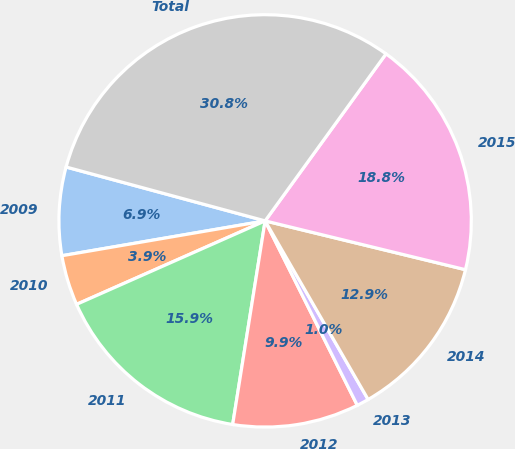Convert chart to OTSL. <chart><loc_0><loc_0><loc_500><loc_500><pie_chart><fcel>2009<fcel>2010<fcel>2011<fcel>2012<fcel>2013<fcel>2014<fcel>2015<fcel>Total<nl><fcel>6.91%<fcel>3.93%<fcel>15.85%<fcel>9.89%<fcel>0.95%<fcel>12.87%<fcel>18.83%<fcel>30.76%<nl></chart> 